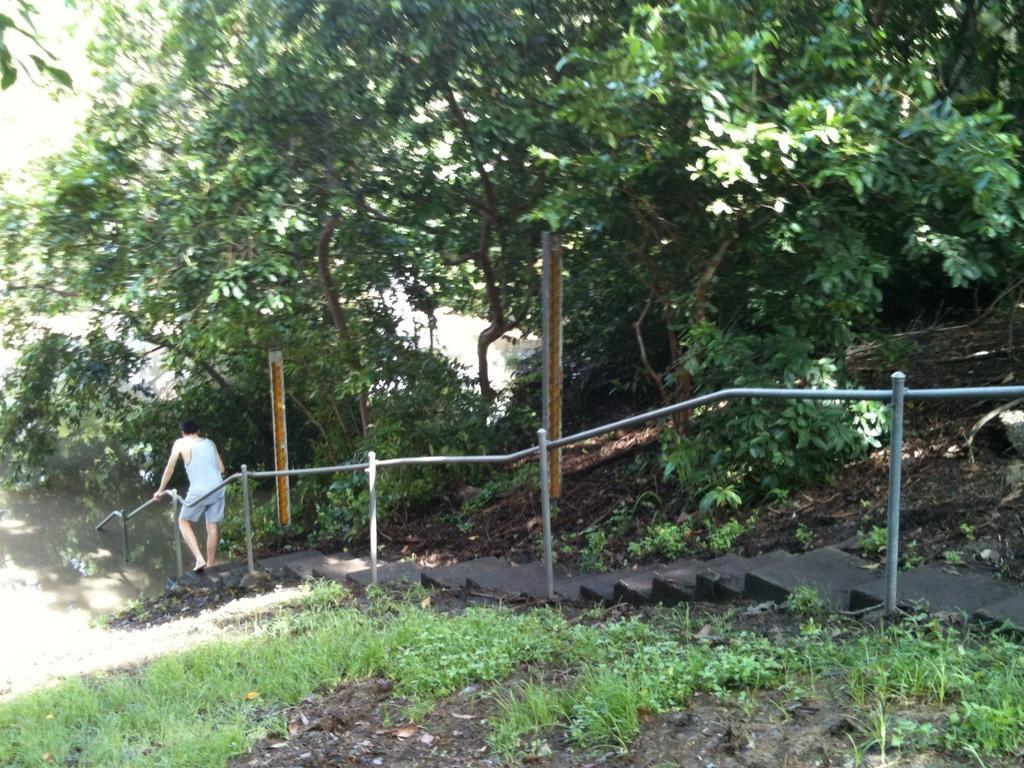Describe this image in one or two sentences. In this picture we can see a person is walking on the steps. On the left side of the person there are iron grilles. In front of the person there is water and trees. On the right side of the person there are poles and plants. 